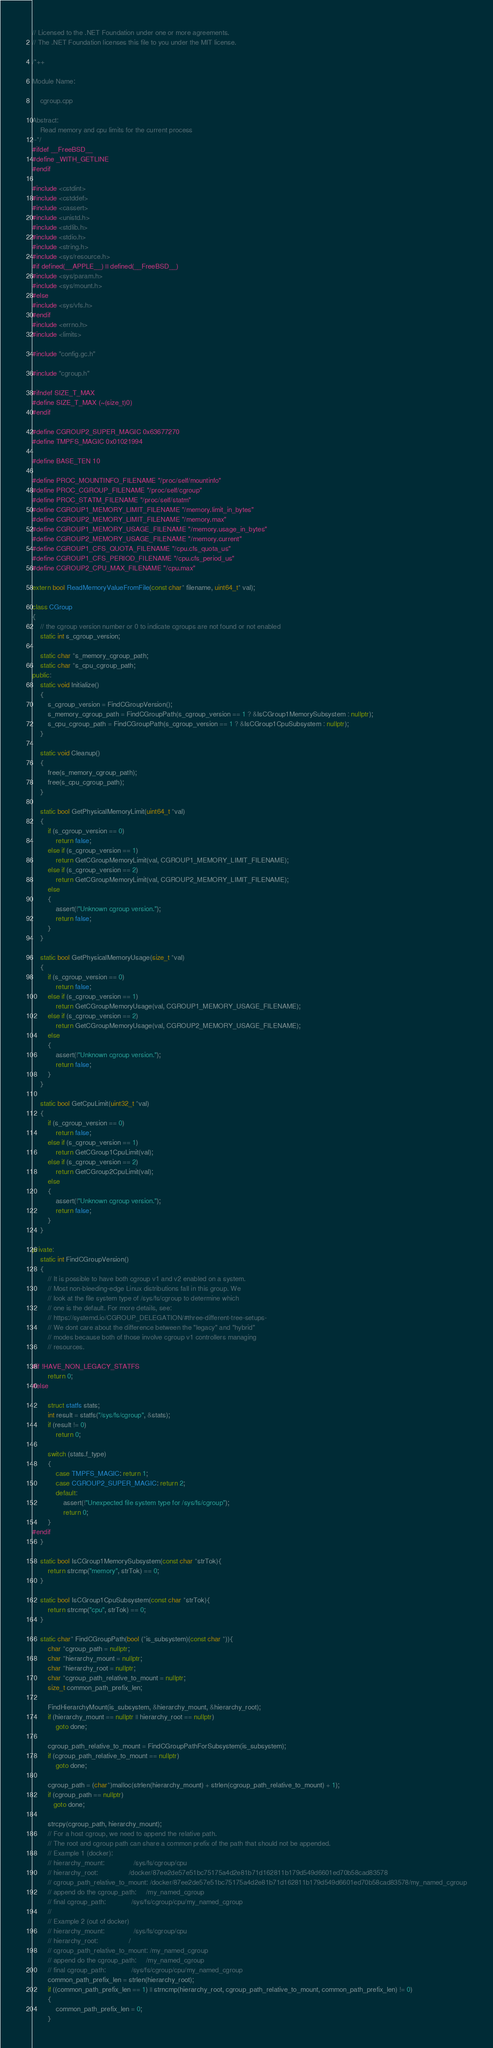<code> <loc_0><loc_0><loc_500><loc_500><_C++_>// Licensed to the .NET Foundation under one or more agreements.
// The .NET Foundation licenses this file to you under the MIT license.

/*++

Module Name:

    cgroup.cpp

Abstract:
    Read memory and cpu limits for the current process
--*/
#ifdef __FreeBSD__
#define _WITH_GETLINE
#endif

#include <cstdint>
#include <cstddef>
#include <cassert>
#include <unistd.h>
#include <stdlib.h>
#include <stdio.h>
#include <string.h>
#include <sys/resource.h>
#if defined(__APPLE__) || defined(__FreeBSD__)
#include <sys/param.h>
#include <sys/mount.h>
#else
#include <sys/vfs.h>
#endif
#include <errno.h>
#include <limits>

#include "config.gc.h"

#include "cgroup.h"

#ifndef SIZE_T_MAX
#define SIZE_T_MAX (~(size_t)0)
#endif

#define CGROUP2_SUPER_MAGIC 0x63677270
#define TMPFS_MAGIC 0x01021994

#define BASE_TEN 10

#define PROC_MOUNTINFO_FILENAME "/proc/self/mountinfo"
#define PROC_CGROUP_FILENAME "/proc/self/cgroup"
#define PROC_STATM_FILENAME "/proc/self/statm"
#define CGROUP1_MEMORY_LIMIT_FILENAME "/memory.limit_in_bytes"
#define CGROUP2_MEMORY_LIMIT_FILENAME "/memory.max"
#define CGROUP1_MEMORY_USAGE_FILENAME "/memory.usage_in_bytes"
#define CGROUP2_MEMORY_USAGE_FILENAME "/memory.current"
#define CGROUP1_CFS_QUOTA_FILENAME "/cpu.cfs_quota_us"
#define CGROUP1_CFS_PERIOD_FILENAME "/cpu.cfs_period_us"
#define CGROUP2_CPU_MAX_FILENAME "/cpu.max"

extern bool ReadMemoryValueFromFile(const char* filename, uint64_t* val);

class CGroup
{
    // the cgroup version number or 0 to indicate cgroups are not found or not enabled
    static int s_cgroup_version;

    static char *s_memory_cgroup_path;
    static char *s_cpu_cgroup_path;
public:
    static void Initialize()
    {
        s_cgroup_version = FindCGroupVersion();
        s_memory_cgroup_path = FindCGroupPath(s_cgroup_version == 1 ? &IsCGroup1MemorySubsystem : nullptr);
        s_cpu_cgroup_path = FindCGroupPath(s_cgroup_version == 1 ? &IsCGroup1CpuSubsystem : nullptr);
    }

    static void Cleanup()
    {
        free(s_memory_cgroup_path);
        free(s_cpu_cgroup_path);
    }

    static bool GetPhysicalMemoryLimit(uint64_t *val)
    {
        if (s_cgroup_version == 0)
            return false;
        else if (s_cgroup_version == 1)
            return GetCGroupMemoryLimit(val, CGROUP1_MEMORY_LIMIT_FILENAME);
        else if (s_cgroup_version == 2)
            return GetCGroupMemoryLimit(val, CGROUP2_MEMORY_LIMIT_FILENAME);
        else
        {
            assert(!"Unknown cgroup version.");
            return false;
        }
    }

    static bool GetPhysicalMemoryUsage(size_t *val)
    {
        if (s_cgroup_version == 0)
            return false;
        else if (s_cgroup_version == 1)
            return GetCGroupMemoryUsage(val, CGROUP1_MEMORY_USAGE_FILENAME);
        else if (s_cgroup_version == 2)
            return GetCGroupMemoryUsage(val, CGROUP2_MEMORY_USAGE_FILENAME);
        else
        {
            assert(!"Unknown cgroup version.");
            return false;
        }
    }

    static bool GetCpuLimit(uint32_t *val)
    {
        if (s_cgroup_version == 0)
            return false;
        else if (s_cgroup_version == 1)
            return GetCGroup1CpuLimit(val);
        else if (s_cgroup_version == 2)
            return GetCGroup2CpuLimit(val);
        else
        {
            assert(!"Unknown cgroup version.");
            return false;
        }
    }

private:
    static int FindCGroupVersion()
    {
        // It is possible to have both cgroup v1 and v2 enabled on a system.
        // Most non-bleeding-edge Linux distributions fall in this group. We
        // look at the file system type of /sys/fs/cgroup to determine which
        // one is the default. For more details, see:
        // https://systemd.io/CGROUP_DELEGATION/#three-different-tree-setups-
        // We dont care about the difference between the "legacy" and "hybrid"
        // modes because both of those involve cgroup v1 controllers managing
        // resources.

#if !HAVE_NON_LEGACY_STATFS
        return 0;
#else

        struct statfs stats;
        int result = statfs("/sys/fs/cgroup", &stats);
        if (result != 0)
            return 0;

        switch (stats.f_type)
        {
            case TMPFS_MAGIC: return 1;
            case CGROUP2_SUPER_MAGIC: return 2;
            default:
                assert(!"Unexpected file system type for /sys/fs/cgroup");
                return 0;
        }
#endif
    }

    static bool IsCGroup1MemorySubsystem(const char *strTok){
        return strcmp("memory", strTok) == 0;
    }

    static bool IsCGroup1CpuSubsystem(const char *strTok){
        return strcmp("cpu", strTok) == 0;
    }

    static char* FindCGroupPath(bool (*is_subsystem)(const char *)){
        char *cgroup_path = nullptr;
        char *hierarchy_mount = nullptr;
        char *hierarchy_root = nullptr;
        char *cgroup_path_relative_to_mount = nullptr;
        size_t common_path_prefix_len;

        FindHierarchyMount(is_subsystem, &hierarchy_mount, &hierarchy_root);
        if (hierarchy_mount == nullptr || hierarchy_root == nullptr)
            goto done;

        cgroup_path_relative_to_mount = FindCGroupPathForSubsystem(is_subsystem);
        if (cgroup_path_relative_to_mount == nullptr)
            goto done;

        cgroup_path = (char*)malloc(strlen(hierarchy_mount) + strlen(cgroup_path_relative_to_mount) + 1);
        if (cgroup_path == nullptr)
           goto done;

        strcpy(cgroup_path, hierarchy_mount);
        // For a host cgroup, we need to append the relative path.
        // The root and cgroup path can share a common prefix of the path that should not be appended.
        // Example 1 (docker):
        // hierarchy_mount:               /sys/fs/cgroup/cpu
        // hierarchy_root:                /docker/87ee2de57e51bc75175a4d2e81b71d162811b179d549d6601ed70b58cad83578
        // cgroup_path_relative_to_mount: /docker/87ee2de57e51bc75175a4d2e81b71d162811b179d549d6601ed70b58cad83578/my_named_cgroup
        // append do the cgroup_path:     /my_named_cgroup
        // final cgroup_path:             /sys/fs/cgroup/cpu/my_named_cgroup
        //
        // Example 2 (out of docker)
        // hierarchy_mount:               /sys/fs/cgroup/cpu
        // hierarchy_root:                /
        // cgroup_path_relative_to_mount: /my_named_cgroup
        // append do the cgroup_path:     /my_named_cgroup
        // final cgroup_path:             /sys/fs/cgroup/cpu/my_named_cgroup
        common_path_prefix_len = strlen(hierarchy_root);
        if ((common_path_prefix_len == 1) || strncmp(hierarchy_root, cgroup_path_relative_to_mount, common_path_prefix_len) != 0)
        {
            common_path_prefix_len = 0;
        }
</code> 